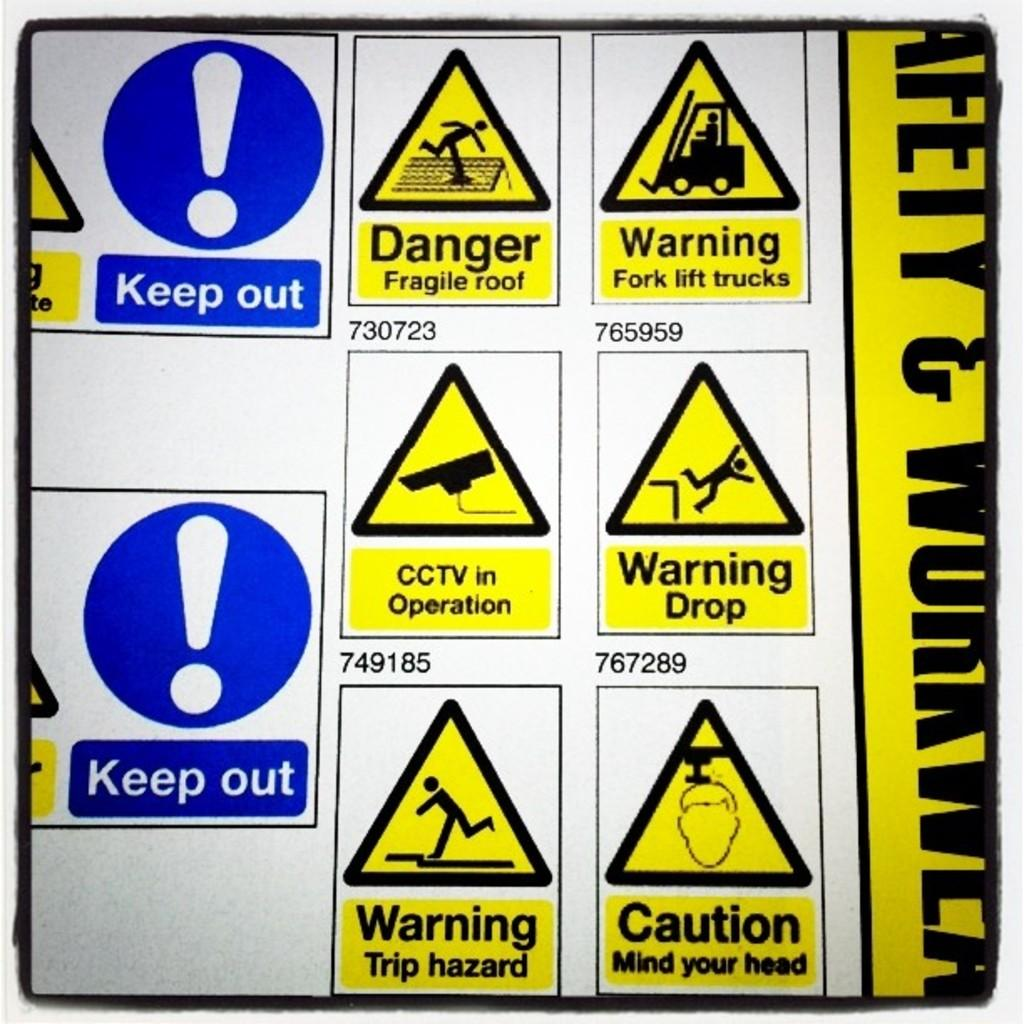<image>
Share a concise interpretation of the image provided. A large sign with many different caution signs and keep out signs on it. 